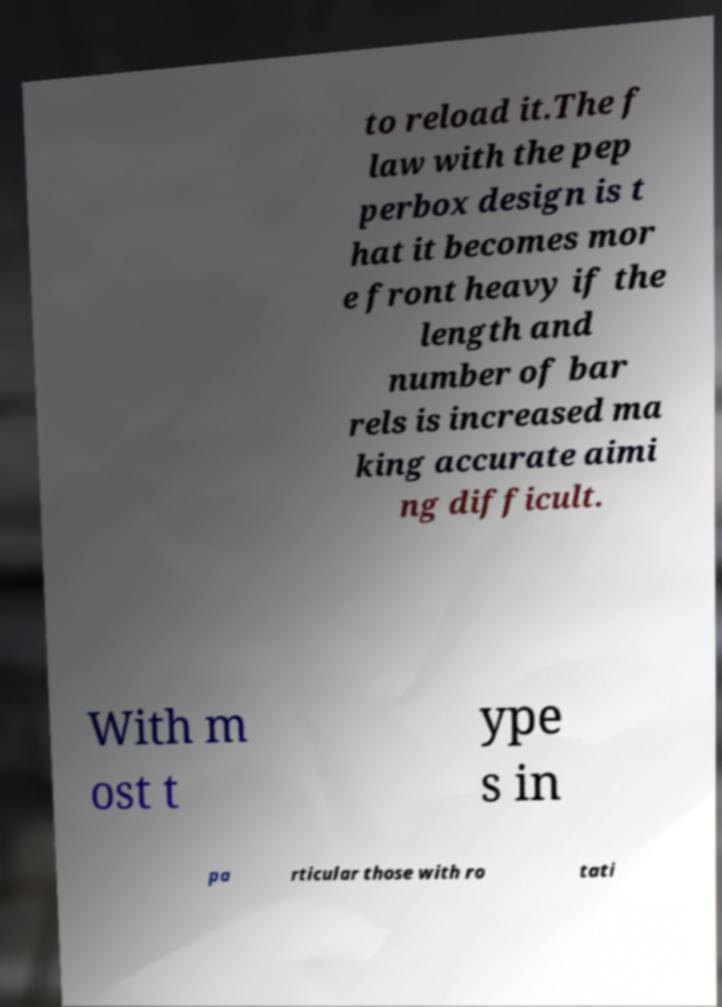Could you extract and type out the text from this image? to reload it.The f law with the pep perbox design is t hat it becomes mor e front heavy if the length and number of bar rels is increased ma king accurate aimi ng difficult. With m ost t ype s in pa rticular those with ro tati 